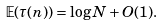Convert formula to latex. <formula><loc_0><loc_0><loc_500><loc_500>\mathbb { E } ( \tau ( n ) ) = \log N + O ( 1 ) .</formula> 